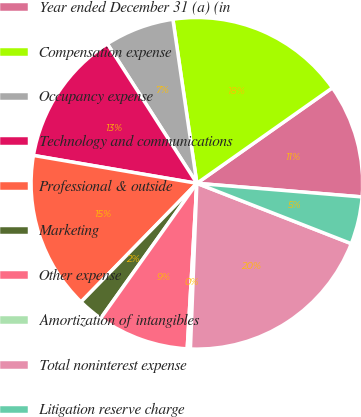Convert chart. <chart><loc_0><loc_0><loc_500><loc_500><pie_chart><fcel>Year ended December 31 (a) (in<fcel>Compensation expense<fcel>Occupancy expense<fcel>Technology and communications<fcel>Professional & outside<fcel>Marketing<fcel>Other expense<fcel>Amortization of intangibles<fcel>Total noninterest expense<fcel>Litigation reserve charge<nl><fcel>11.08%<fcel>17.54%<fcel>6.77%<fcel>13.23%<fcel>15.38%<fcel>2.46%<fcel>8.92%<fcel>0.31%<fcel>19.69%<fcel>4.62%<nl></chart> 